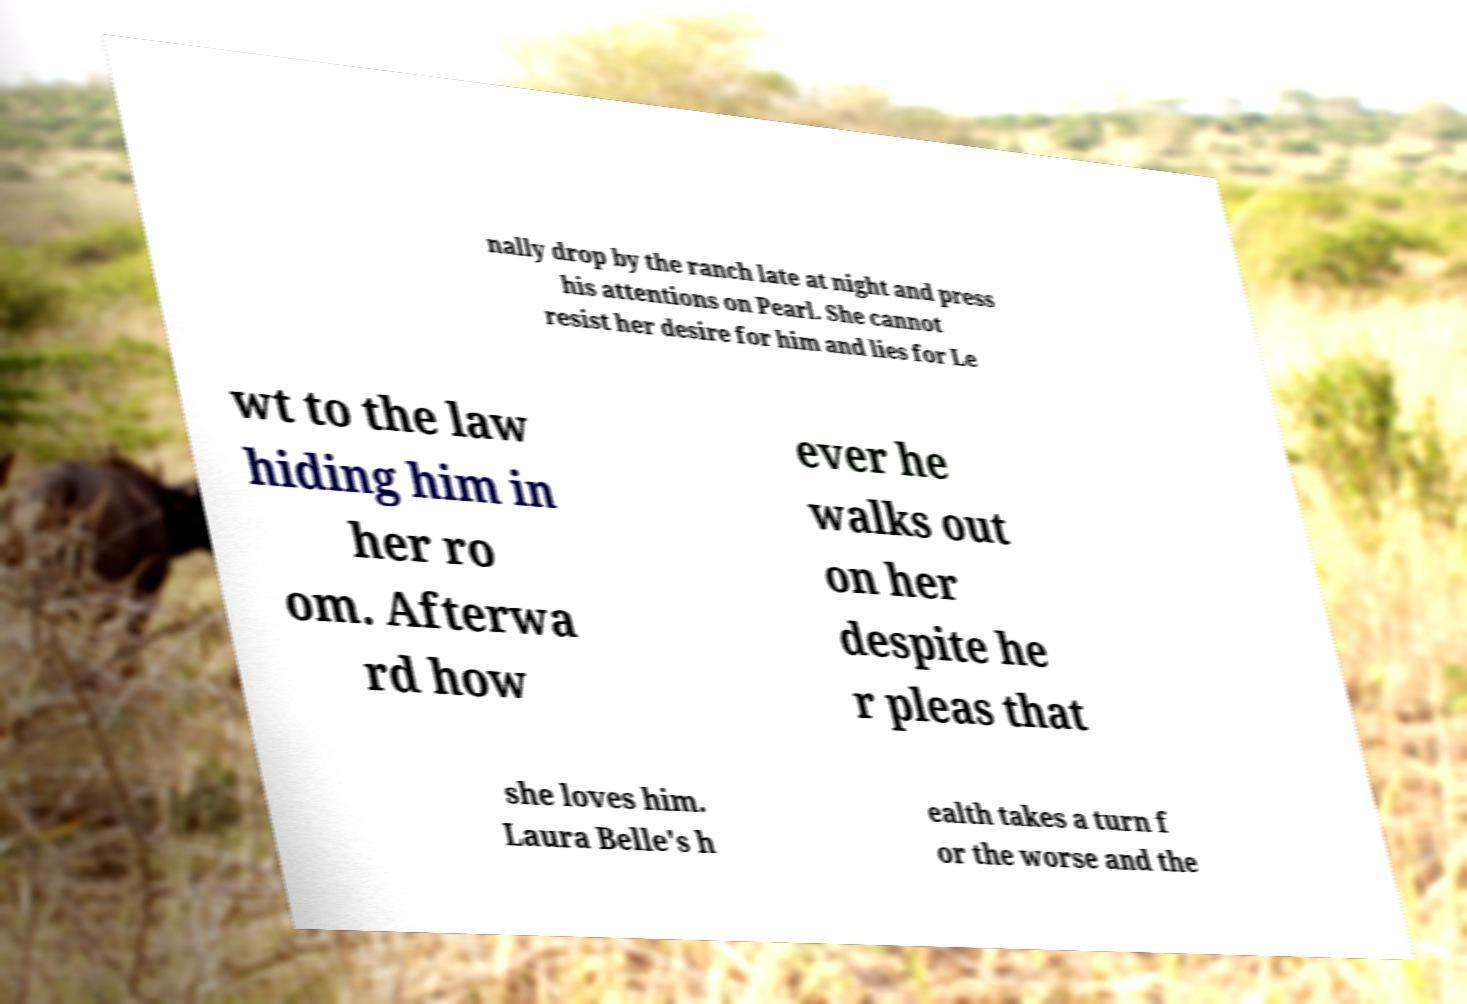Please read and relay the text visible in this image. What does it say? nally drop by the ranch late at night and press his attentions on Pearl. She cannot resist her desire for him and lies for Le wt to the law hiding him in her ro om. Afterwa rd how ever he walks out on her despite he r pleas that she loves him. Laura Belle's h ealth takes a turn f or the worse and the 